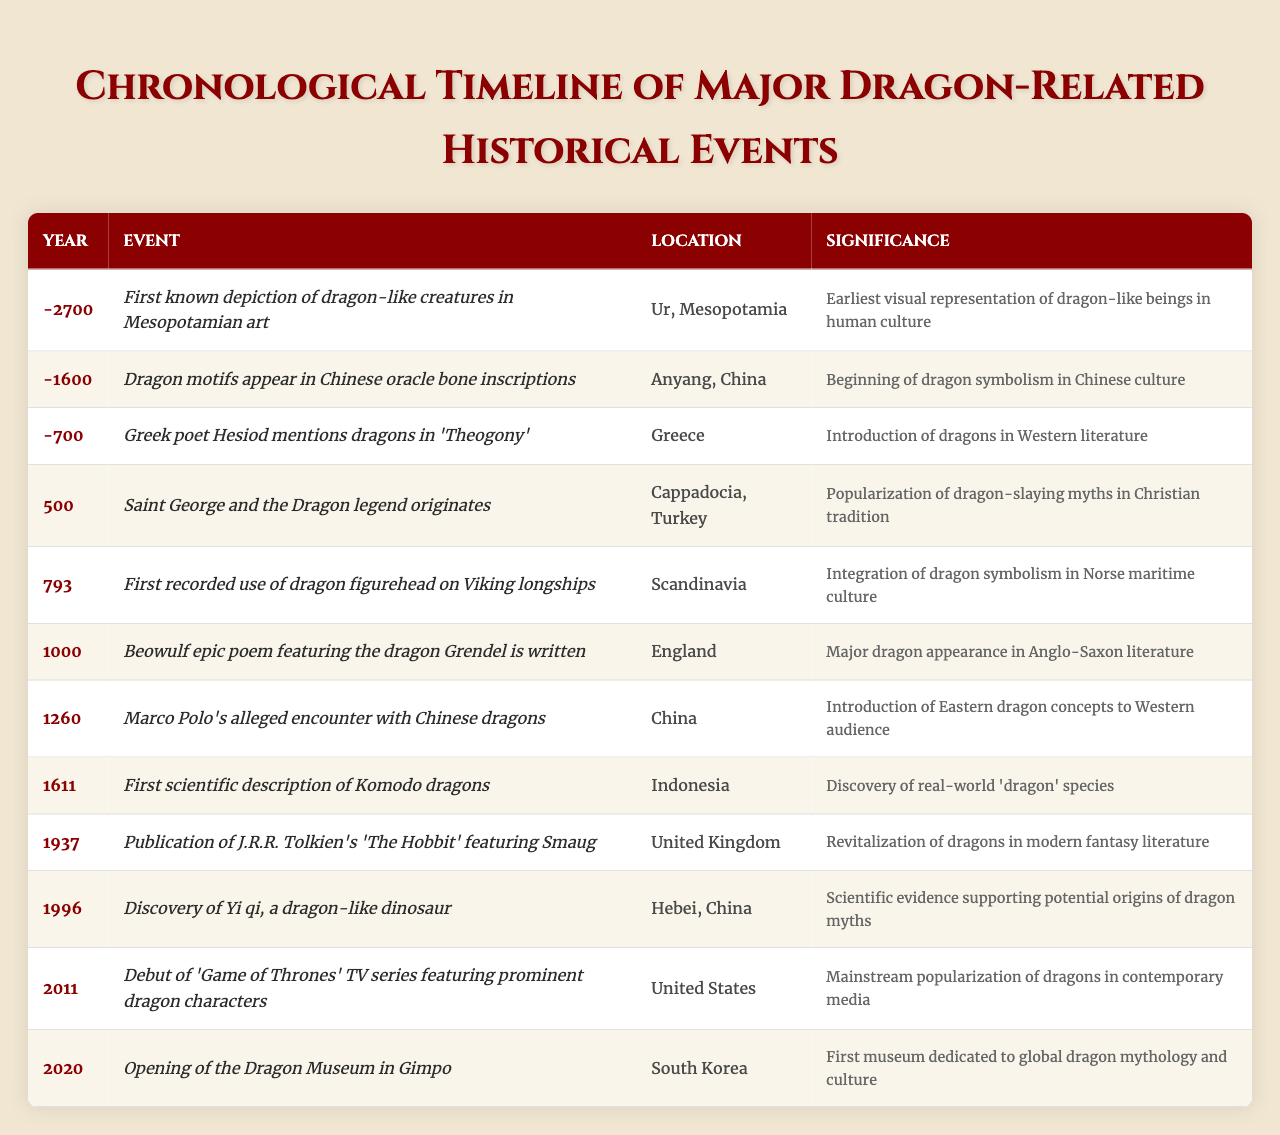What is the first recorded dragon-related event in history according to the table? The earliest event recorded in the table is from the year -2700, which describes the first known depiction of dragon-like creatures in Mesopotamian art located in Ur, Mesopotamia.
Answer: First known depiction of dragon-like creatures in -2700 What year did the first scientific description of Komodo dragons occur? The table lists the year 1611 as the time when the first scientific description of Komodo dragons was made.
Answer: 1611 Which location is associated with the legend of Saint George and the Dragon? According to the table, the legend of Saint George and the Dragon originated in Cappadocia, Turkey, as noted in the event from the year 500.
Answer: Cappadocia, Turkey How many years passed between the first depiction of dragon-like creatures and the publication of J.R.R. Tolkien's 'The Hobbit'? The first depiction in -2700 and the publication of 'The Hobbit' in 1937 is a difference of 4637 years. Thus, calculating: 1937 - (-2700) = 1937 + 2700 = 4637.
Answer: 4637 years Is it true that dragon motifs appeared in Chinese culture before the year 0? The table shows that dragon motifs appeared in Chinese oracle bone inscriptions in -1600, which is indeed before the year 0. Therefore, the statement is true.
Answer: Yes Which two events in the table represent the introduction of dragon concepts to Western culture? The introduction of dragon concepts to Western culture can be linked to the mention of dragons by Hesiod in Greece around -700 and Marco Polo's alleged encounter with Chinese dragons in 1260. Both events signify the cross-cultural influence of dragon imagery.
Answer: Hesiod's mention and Marco Polo's encounter What was the significance of the dragon figurehead used by Vikings in 793? The entry for 793 indicates the integration of dragon symbolism into Norse maritime culture through the first recorded use of dragon figureheads on Viking longships. This showcases the cultural importance of dragons in their seafaring identities.
Answer: Integration of dragon symbolism into Norse maritime culture How has the perception of dragons shifted from ancient to modern times as depicted in the table? The table presents a broad timeline: starting with ancient depictions in -2700, through the literary introductions in Greek and Anglo-Saxon culture, to the revitalization of dragons in modern fantasy literature with Tolkien's works in 1937, and further to dragons being popularized in contemporary media with the 'Game of Thrones' series in 2011. This suggests an evolving perception from mythological beings to characters in popular culture.
Answer: From mythological beings to contemporary media characters What event relates to a real-world discovery of a dragon-like species? The event in 1611 concerning the first scientific description of Komodo dragons represents the real-world discovery of a species resembling dragons, thus bridging myth and reality.
Answer: First scientific description of Komodo dragons Which event happened last in the timeline provided? The last event noted in the table is the opening of the Dragon Museum in Gimpo, South Korea, in the year 2020. This is the final entry listed chronologically.
Answer: Opening of the Dragon Museum in 2020 How many events related to dragon mythology occurred in China according to the table? The table shows two events connected specifically to dragon mythology in China: the dragon motifs in oracle bone inscriptions in -1600, and Marco Polo's encounter with Chinese dragons in 1260. Thus, there are two events.
Answer: Two events 